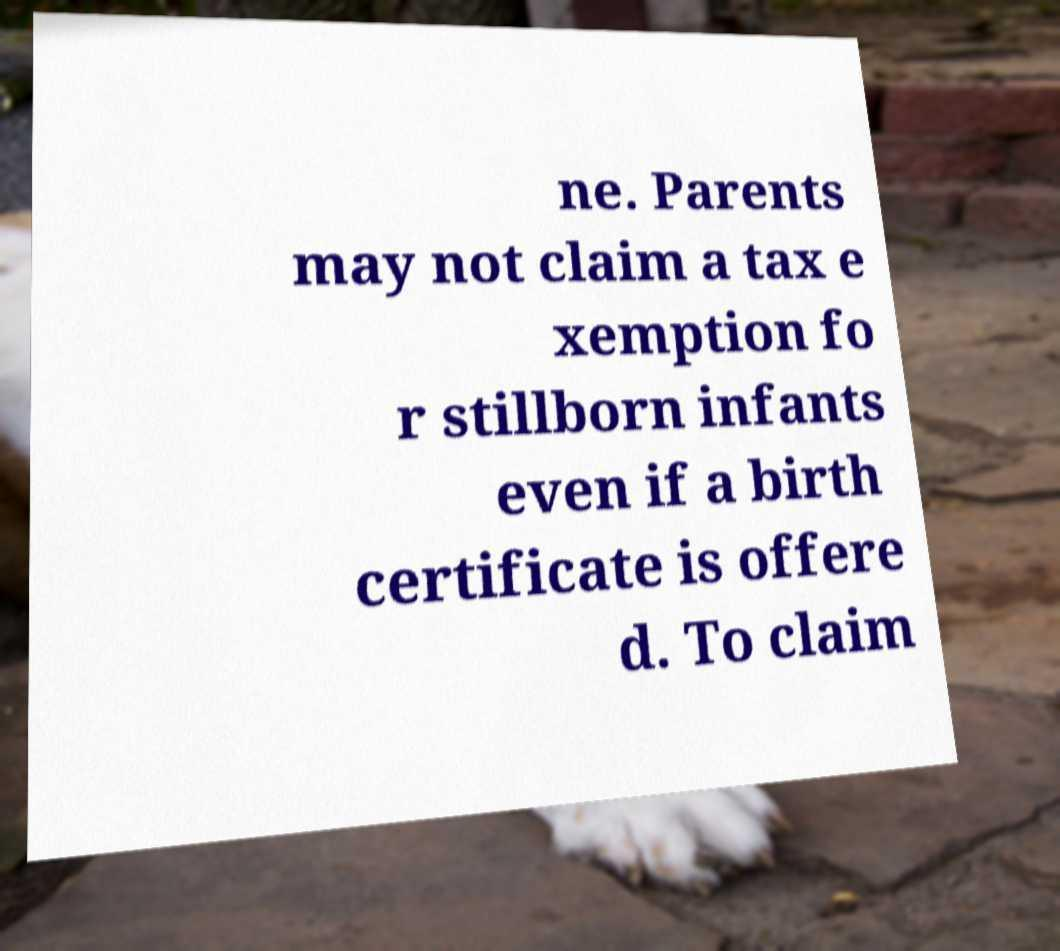Can you read and provide the text displayed in the image?This photo seems to have some interesting text. Can you extract and type it out for me? ne. Parents may not claim a tax e xemption fo r stillborn infants even if a birth certificate is offere d. To claim 